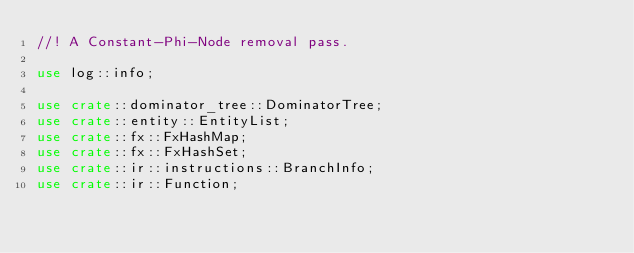<code> <loc_0><loc_0><loc_500><loc_500><_Rust_>//! A Constant-Phi-Node removal pass.

use log::info;

use crate::dominator_tree::DominatorTree;
use crate::entity::EntityList;
use crate::fx::FxHashMap;
use crate::fx::FxHashSet;
use crate::ir::instructions::BranchInfo;
use crate::ir::Function;</code> 